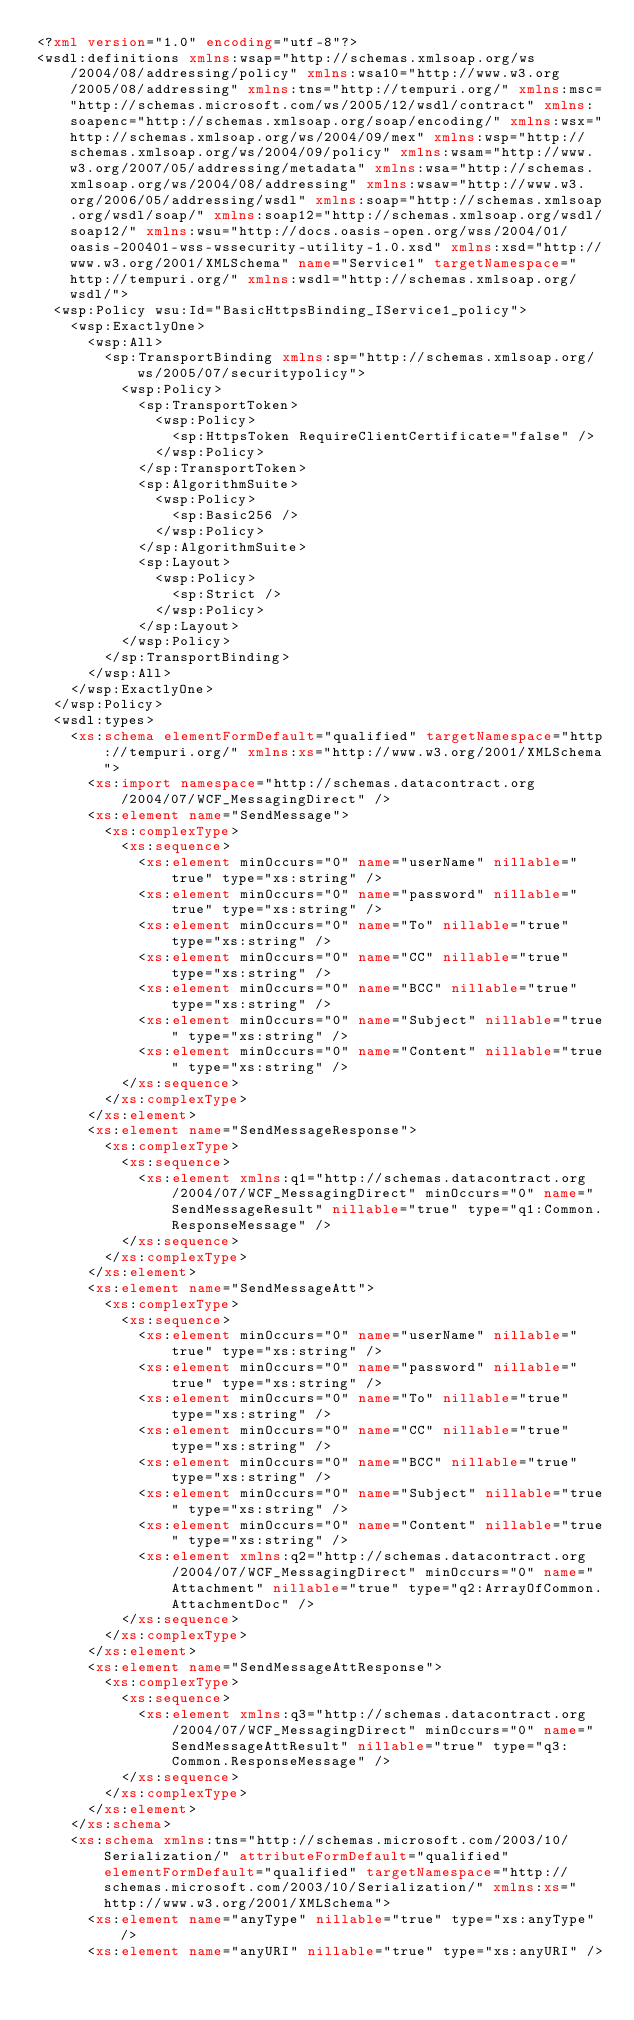<code> <loc_0><loc_0><loc_500><loc_500><_XML_><?xml version="1.0" encoding="utf-8"?>
<wsdl:definitions xmlns:wsap="http://schemas.xmlsoap.org/ws/2004/08/addressing/policy" xmlns:wsa10="http://www.w3.org/2005/08/addressing" xmlns:tns="http://tempuri.org/" xmlns:msc="http://schemas.microsoft.com/ws/2005/12/wsdl/contract" xmlns:soapenc="http://schemas.xmlsoap.org/soap/encoding/" xmlns:wsx="http://schemas.xmlsoap.org/ws/2004/09/mex" xmlns:wsp="http://schemas.xmlsoap.org/ws/2004/09/policy" xmlns:wsam="http://www.w3.org/2007/05/addressing/metadata" xmlns:wsa="http://schemas.xmlsoap.org/ws/2004/08/addressing" xmlns:wsaw="http://www.w3.org/2006/05/addressing/wsdl" xmlns:soap="http://schemas.xmlsoap.org/wsdl/soap/" xmlns:soap12="http://schemas.xmlsoap.org/wsdl/soap12/" xmlns:wsu="http://docs.oasis-open.org/wss/2004/01/oasis-200401-wss-wssecurity-utility-1.0.xsd" xmlns:xsd="http://www.w3.org/2001/XMLSchema" name="Service1" targetNamespace="http://tempuri.org/" xmlns:wsdl="http://schemas.xmlsoap.org/wsdl/">
  <wsp:Policy wsu:Id="BasicHttpsBinding_IService1_policy">
    <wsp:ExactlyOne>
      <wsp:All>
        <sp:TransportBinding xmlns:sp="http://schemas.xmlsoap.org/ws/2005/07/securitypolicy">
          <wsp:Policy>
            <sp:TransportToken>
              <wsp:Policy>
                <sp:HttpsToken RequireClientCertificate="false" />
              </wsp:Policy>
            </sp:TransportToken>
            <sp:AlgorithmSuite>
              <wsp:Policy>
                <sp:Basic256 />
              </wsp:Policy>
            </sp:AlgorithmSuite>
            <sp:Layout>
              <wsp:Policy>
                <sp:Strict />
              </wsp:Policy>
            </sp:Layout>
          </wsp:Policy>
        </sp:TransportBinding>
      </wsp:All>
    </wsp:ExactlyOne>
  </wsp:Policy>
  <wsdl:types>
    <xs:schema elementFormDefault="qualified" targetNamespace="http://tempuri.org/" xmlns:xs="http://www.w3.org/2001/XMLSchema">
      <xs:import namespace="http://schemas.datacontract.org/2004/07/WCF_MessagingDirect" />
      <xs:element name="SendMessage">
        <xs:complexType>
          <xs:sequence>
            <xs:element minOccurs="0" name="userName" nillable="true" type="xs:string" />
            <xs:element minOccurs="0" name="password" nillable="true" type="xs:string" />
            <xs:element minOccurs="0" name="To" nillable="true" type="xs:string" />
            <xs:element minOccurs="0" name="CC" nillable="true" type="xs:string" />
            <xs:element minOccurs="0" name="BCC" nillable="true" type="xs:string" />
            <xs:element minOccurs="0" name="Subject" nillable="true" type="xs:string" />
            <xs:element minOccurs="0" name="Content" nillable="true" type="xs:string" />
          </xs:sequence>
        </xs:complexType>
      </xs:element>
      <xs:element name="SendMessageResponse">
        <xs:complexType>
          <xs:sequence>
            <xs:element xmlns:q1="http://schemas.datacontract.org/2004/07/WCF_MessagingDirect" minOccurs="0" name="SendMessageResult" nillable="true" type="q1:Common.ResponseMessage" />
          </xs:sequence>
        </xs:complexType>
      </xs:element>
      <xs:element name="SendMessageAtt">
        <xs:complexType>
          <xs:sequence>
            <xs:element minOccurs="0" name="userName" nillable="true" type="xs:string" />
            <xs:element minOccurs="0" name="password" nillable="true" type="xs:string" />
            <xs:element minOccurs="0" name="To" nillable="true" type="xs:string" />
            <xs:element minOccurs="0" name="CC" nillable="true" type="xs:string" />
            <xs:element minOccurs="0" name="BCC" nillable="true" type="xs:string" />
            <xs:element minOccurs="0" name="Subject" nillable="true" type="xs:string" />
            <xs:element minOccurs="0" name="Content" nillable="true" type="xs:string" />
            <xs:element xmlns:q2="http://schemas.datacontract.org/2004/07/WCF_MessagingDirect" minOccurs="0" name="Attachment" nillable="true" type="q2:ArrayOfCommon.AttachmentDoc" />
          </xs:sequence>
        </xs:complexType>
      </xs:element>
      <xs:element name="SendMessageAttResponse">
        <xs:complexType>
          <xs:sequence>
            <xs:element xmlns:q3="http://schemas.datacontract.org/2004/07/WCF_MessagingDirect" minOccurs="0" name="SendMessageAttResult" nillable="true" type="q3:Common.ResponseMessage" />
          </xs:sequence>
        </xs:complexType>
      </xs:element>
    </xs:schema>
    <xs:schema xmlns:tns="http://schemas.microsoft.com/2003/10/Serialization/" attributeFormDefault="qualified" elementFormDefault="qualified" targetNamespace="http://schemas.microsoft.com/2003/10/Serialization/" xmlns:xs="http://www.w3.org/2001/XMLSchema">
      <xs:element name="anyType" nillable="true" type="xs:anyType" />
      <xs:element name="anyURI" nillable="true" type="xs:anyURI" /></code> 